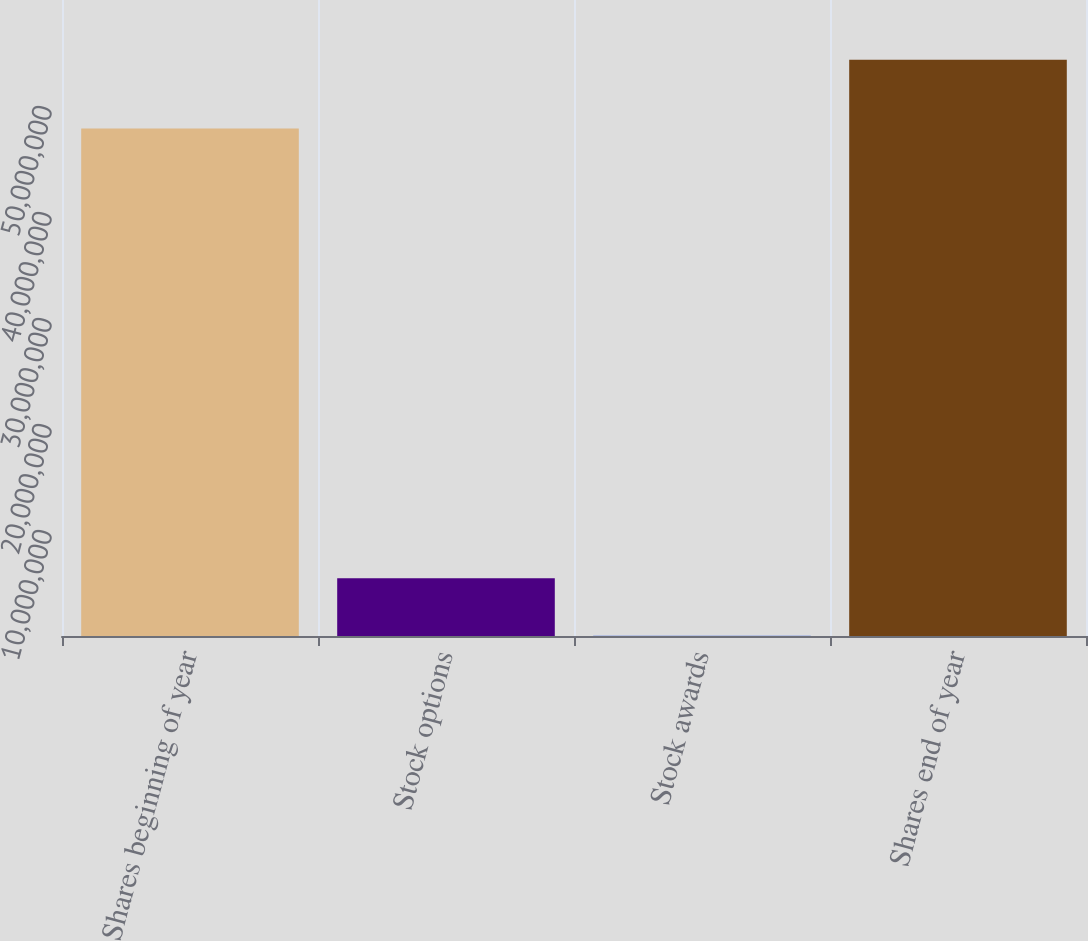Convert chart to OTSL. <chart><loc_0><loc_0><loc_500><loc_500><bar_chart><fcel>Shares beginning of year<fcel>Stock options<fcel>Stock awards<fcel>Shares end of year<nl><fcel>4.78723e+07<fcel>5.45054e+06<fcel>14745<fcel>5.43727e+07<nl></chart> 